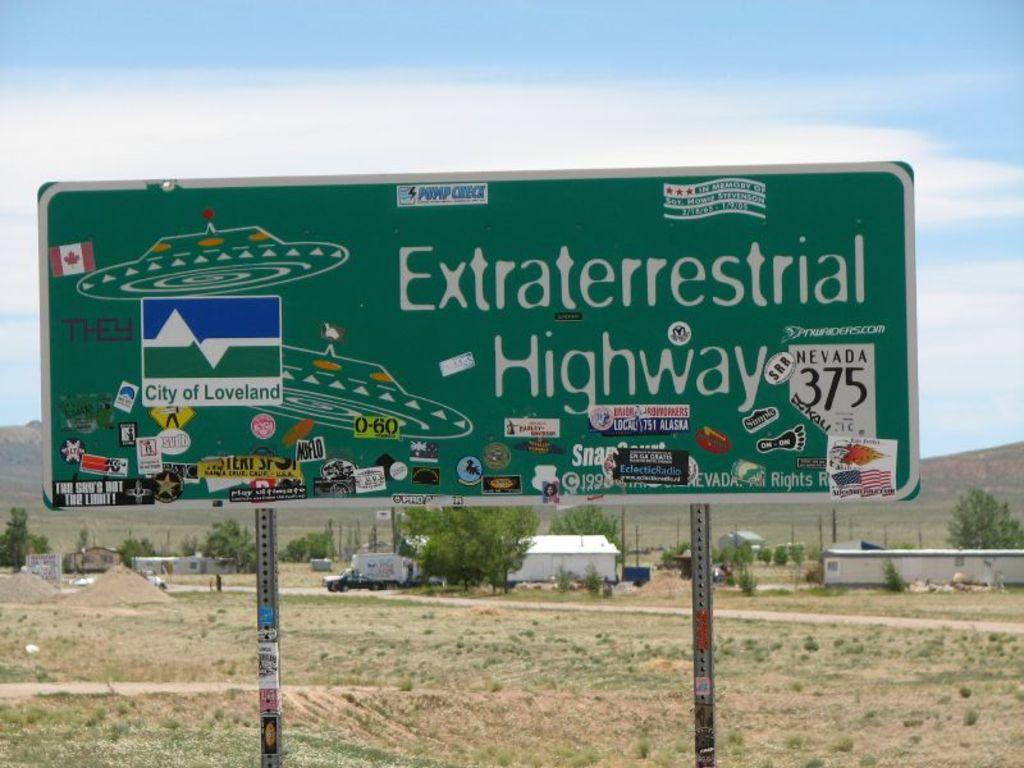What city are we in now?
Offer a very short reply. Loveland. Does that sign post imply there are ufos in that area?
Offer a very short reply. Yes. 